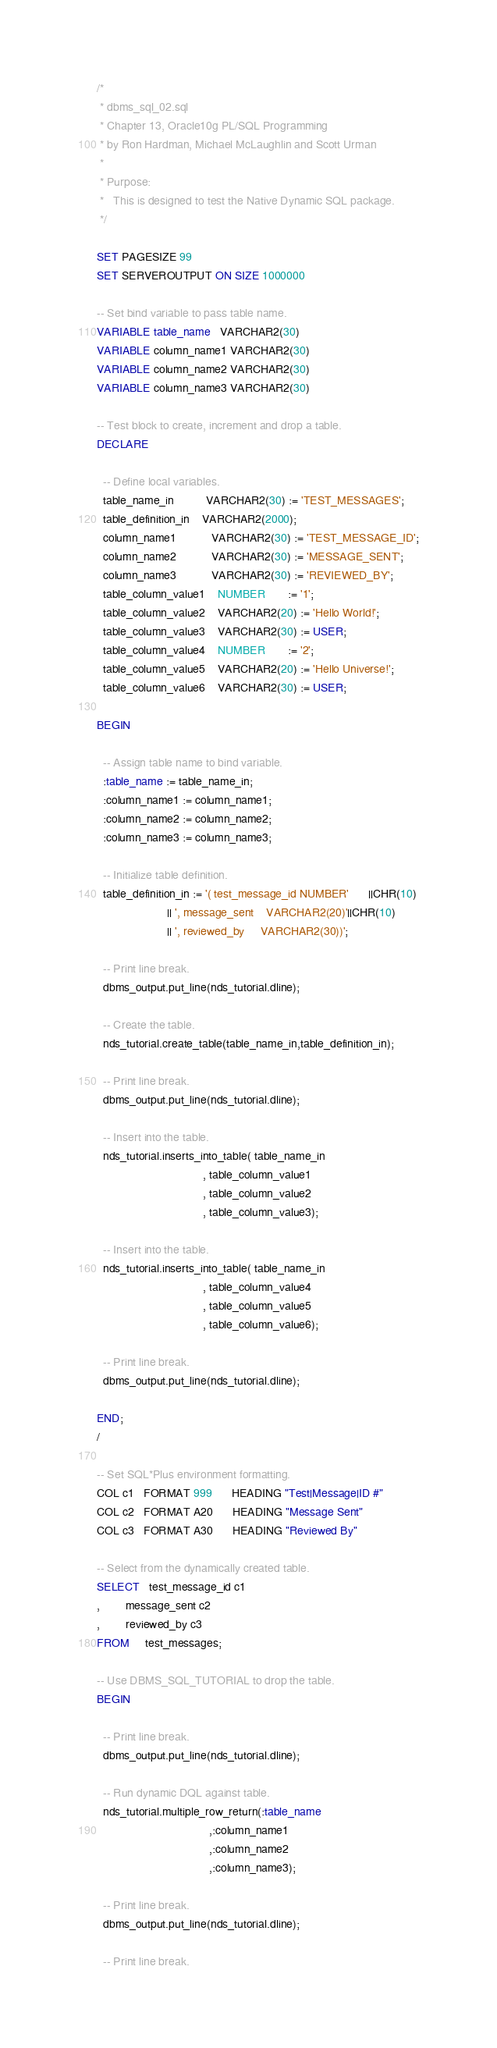Convert code to text. <code><loc_0><loc_0><loc_500><loc_500><_SQL_>/*
 * dbms_sql_02.sql
 * Chapter 13, Oracle10g PL/SQL Programming
 * by Ron Hardman, Michael McLaughlin and Scott Urman
 *
 * Purpose:
 *   This is designed to test the Native Dynamic SQL package.
 */

SET PAGESIZE 99
SET SERVEROUTPUT ON SIZE 1000000

-- Set bind variable to pass table name.
VARIABLE table_name   VARCHAR2(30)
VARIABLE column_name1 VARCHAR2(30)
VARIABLE column_name2 VARCHAR2(30)
VARIABLE column_name3 VARCHAR2(30)

-- Test block to create, increment and drop a table.
DECLARE

  -- Define local variables.
  table_name_in          VARCHAR2(30) := 'TEST_MESSAGES';
  table_definition_in    VARCHAR2(2000);
  column_name1           VARCHAR2(30) := 'TEST_MESSAGE_ID';
  column_name2           VARCHAR2(30) := 'MESSAGE_SENT';
  column_name3           VARCHAR2(30) := 'REVIEWED_BY';
  table_column_value1    NUMBER       := '1';
  table_column_value2    VARCHAR2(20) := 'Hello World!';
  table_column_value3    VARCHAR2(30) := USER;
  table_column_value4    NUMBER       := '2';
  table_column_value5    VARCHAR2(20) := 'Hello Universe!';
  table_column_value6    VARCHAR2(30) := USER;

BEGIN

  -- Assign table name to bind variable.
  :table_name := table_name_in;
  :column_name1 := column_name1;
  :column_name2 := column_name2;
  :column_name3 := column_name3;

  -- Initialize table definition.
  table_definition_in := '( test_message_id NUMBER'      ||CHR(10)
                      || ', message_sent    VARCHAR2(20)'||CHR(10)
                      || ', reviewed_by     VARCHAR2(30))';

  -- Print line break.
  dbms_output.put_line(nds_tutorial.dline);

  -- Create the table.
  nds_tutorial.create_table(table_name_in,table_definition_in);

  -- Print line break.
  dbms_output.put_line(nds_tutorial.dline);

  -- Insert into the table.
  nds_tutorial.inserts_into_table( table_name_in
                                 , table_column_value1
                                 , table_column_value2
                                 , table_column_value3);

  -- Insert into the table.
  nds_tutorial.inserts_into_table( table_name_in
                                 , table_column_value4
                                 , table_column_value5
                                 , table_column_value6);

  -- Print line break.
  dbms_output.put_line(nds_tutorial.dline);

END;
/

-- Set SQL*Plus environment formatting.
COL c1   FORMAT 999      HEADING "Test|Message|ID #"
COL c2   FORMAT A20      HEADING "Message Sent"
COL c3   FORMAT A30      HEADING "Reviewed By"

-- Select from the dynamically created table.
SELECT   test_message_id c1
,        message_sent c2
,        reviewed_by c3
FROM     test_messages;

-- Use DBMS_SQL_TUTORIAL to drop the table.
BEGIN

  -- Print line break.
  dbms_output.put_line(nds_tutorial.dline);

  -- Run dynamic DQL against table.
  nds_tutorial.multiple_row_return(:table_name
                                   ,:column_name1
                                   ,:column_name2
                                   ,:column_name3);

  -- Print line break.
  dbms_output.put_line(nds_tutorial.dline);

  -- Print line break.</code> 